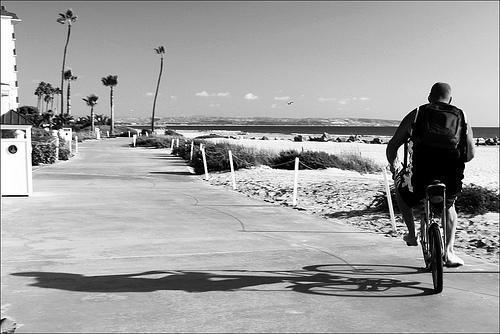How many people are pictured?
Give a very brief answer. 1. How many bikes are there?
Give a very brief answer. 1. How many bikes are pictured?
Give a very brief answer. 1. How many people are riding bikes?
Give a very brief answer. 1. How many bikers are  there?
Give a very brief answer. 1. 